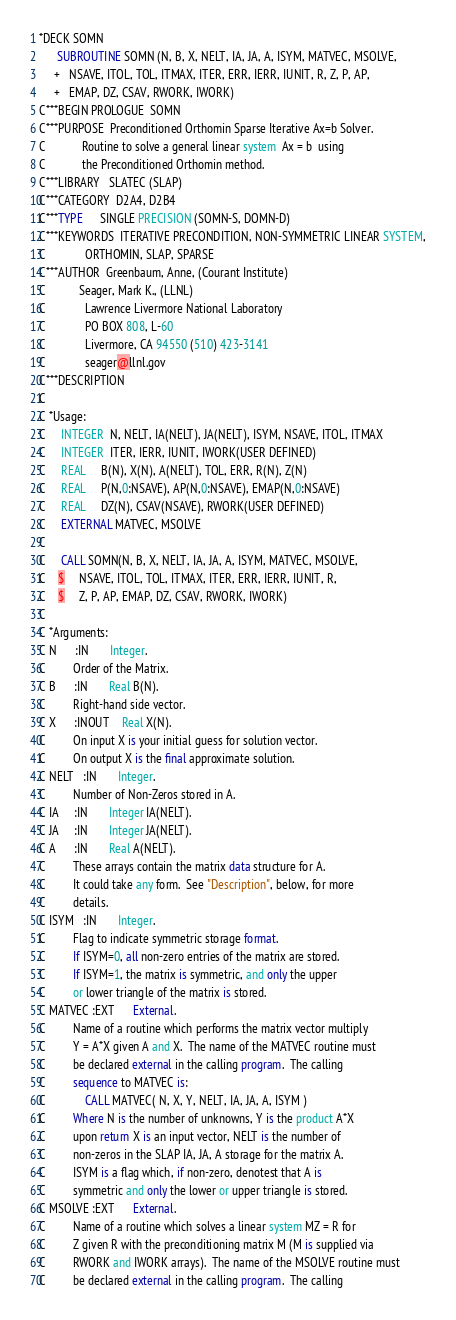<code> <loc_0><loc_0><loc_500><loc_500><_FORTRAN_>*DECK SOMN
      SUBROUTINE SOMN (N, B, X, NELT, IA, JA, A, ISYM, MATVEC, MSOLVE,
     +   NSAVE, ITOL, TOL, ITMAX, ITER, ERR, IERR, IUNIT, R, Z, P, AP,
     +   EMAP, DZ, CSAV, RWORK, IWORK)
C***BEGIN PROLOGUE  SOMN
C***PURPOSE  Preconditioned Orthomin Sparse Iterative Ax=b Solver.
C            Routine to solve a general linear system  Ax = b  using
C            the Preconditioned Orthomin method.
C***LIBRARY   SLATEC (SLAP)
C***CATEGORY  D2A4, D2B4
C***TYPE      SINGLE PRECISION (SOMN-S, DOMN-D)
C***KEYWORDS  ITERATIVE PRECONDITION, NON-SYMMETRIC LINEAR SYSTEM,
C             ORTHOMIN, SLAP, SPARSE
C***AUTHOR  Greenbaum, Anne, (Courant Institute)
C           Seager, Mark K., (LLNL)
C             Lawrence Livermore National Laboratory
C             PO BOX 808, L-60
C             Livermore, CA 94550 (510) 423-3141
C             seager@llnl.gov
C***DESCRIPTION
C
C *Usage:
C     INTEGER  N, NELT, IA(NELT), JA(NELT), ISYM, NSAVE, ITOL, ITMAX
C     INTEGER  ITER, IERR, IUNIT, IWORK(USER DEFINED)
C     REAL     B(N), X(N), A(NELT), TOL, ERR, R(N), Z(N)
C     REAL     P(N,0:NSAVE), AP(N,0:NSAVE), EMAP(N,0:NSAVE)
C     REAL     DZ(N), CSAV(NSAVE), RWORK(USER DEFINED)
C     EXTERNAL MATVEC, MSOLVE
C
C     CALL SOMN(N, B, X, NELT, IA, JA, A, ISYM, MATVEC, MSOLVE,
C    $     NSAVE, ITOL, TOL, ITMAX, ITER, ERR, IERR, IUNIT, R,
C    $     Z, P, AP, EMAP, DZ, CSAV, RWORK, IWORK)
C
C *Arguments:
C N      :IN       Integer.
C         Order of the Matrix.
C B      :IN       Real B(N).
C         Right-hand side vector.
C X      :INOUT    Real X(N).
C         On input X is your initial guess for solution vector.
C         On output X is the final approximate solution.
C NELT   :IN       Integer.
C         Number of Non-Zeros stored in A.
C IA     :IN       Integer IA(NELT).
C JA     :IN       Integer JA(NELT).
C A      :IN       Real A(NELT).
C         These arrays contain the matrix data structure for A.
C         It could take any form.  See "Description", below, for more
C         details.
C ISYM   :IN       Integer.
C         Flag to indicate symmetric storage format.
C         If ISYM=0, all non-zero entries of the matrix are stored.
C         If ISYM=1, the matrix is symmetric, and only the upper
C         or lower triangle of the matrix is stored.
C MATVEC :EXT      External.
C         Name of a routine which performs the matrix vector multiply
C         Y = A*X given A and X.  The name of the MATVEC routine must
C         be declared external in the calling program.  The calling
C         sequence to MATVEC is:
C             CALL MATVEC( N, X, Y, NELT, IA, JA, A, ISYM )
C         Where N is the number of unknowns, Y is the product A*X
C         upon return X is an input vector, NELT is the number of
C         non-zeros in the SLAP IA, JA, A storage for the matrix A.
C         ISYM is a flag which, if non-zero, denotest that A is
C         symmetric and only the lower or upper triangle is stored.
C MSOLVE :EXT      External.
C         Name of a routine which solves a linear system MZ = R for
C         Z given R with the preconditioning matrix M (M is supplied via
C         RWORK and IWORK arrays).  The name of the MSOLVE routine must
C         be declared external in the calling program.  The calling</code> 